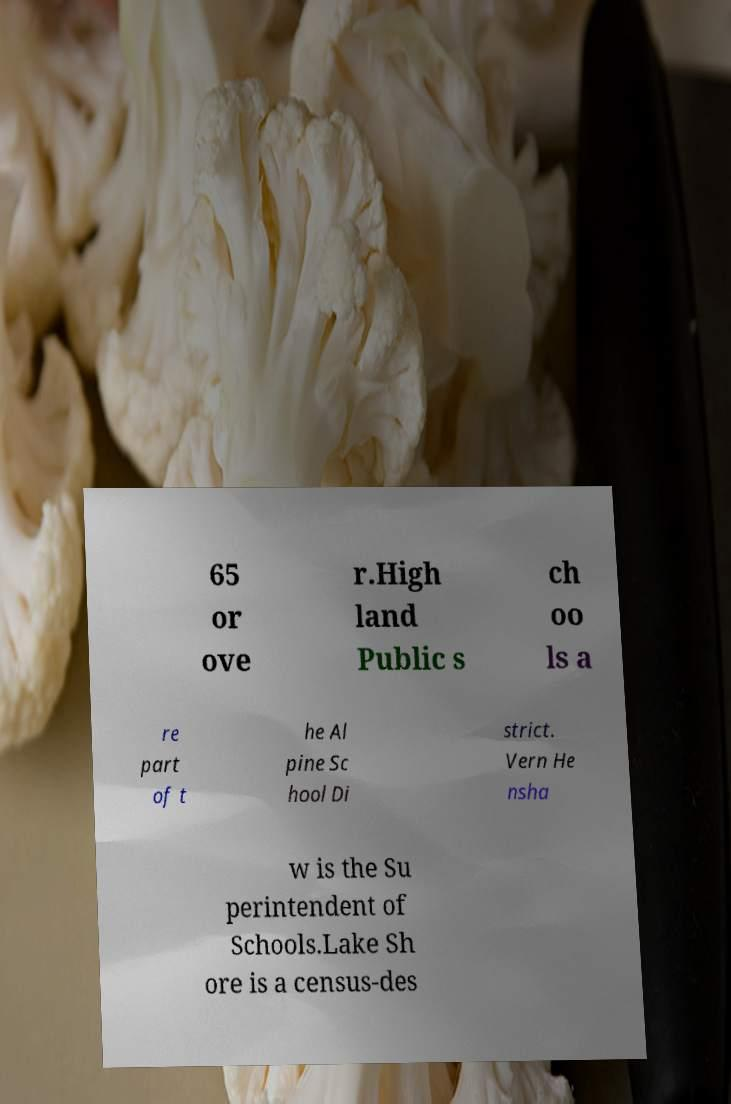Please identify and transcribe the text found in this image. 65 or ove r.High land Public s ch oo ls a re part of t he Al pine Sc hool Di strict. Vern He nsha w is the Su perintendent of Schools.Lake Sh ore is a census-des 